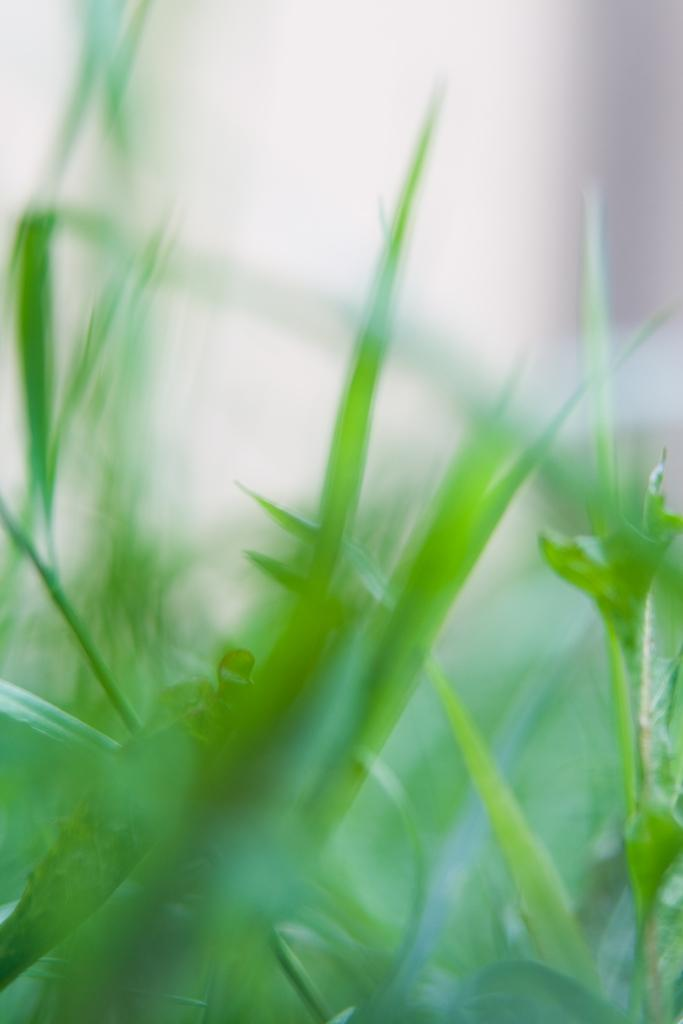What type of living organisms can be seen in the image? Plants can be seen in the image. Can you describe the background of the image? The background of the image is blurred. What type of paste can be seen on the plants in the image? There is no paste present on the plants in the image. How many feathers can be seen on the plants in the image? There are no feathers present on the plants in the image. 